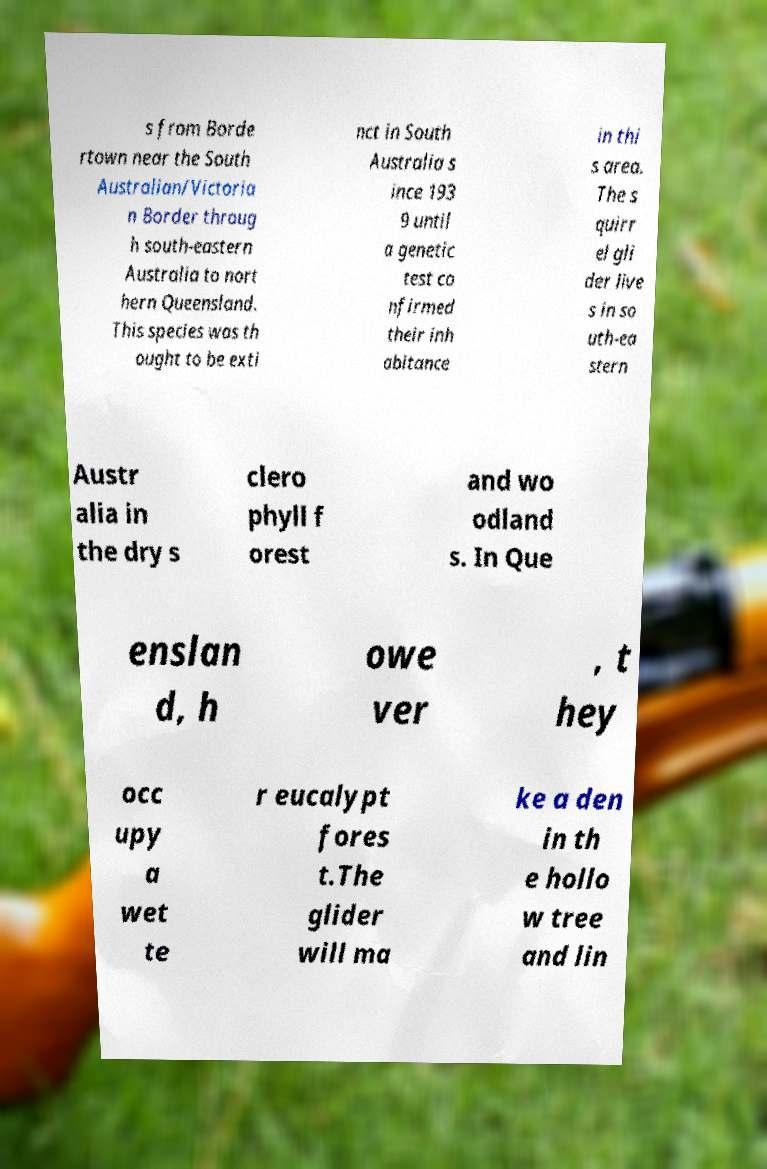There's text embedded in this image that I need extracted. Can you transcribe it verbatim? s from Borde rtown near the South Australian/Victoria n Border throug h south-eastern Australia to nort hern Queensland. This species was th ought to be exti nct in South Australia s ince 193 9 until a genetic test co nfirmed their inh abitance in thi s area. The s quirr el gli der live s in so uth-ea stern Austr alia in the dry s clero phyll f orest and wo odland s. In Que enslan d, h owe ver , t hey occ upy a wet te r eucalypt fores t.The glider will ma ke a den in th e hollo w tree and lin 